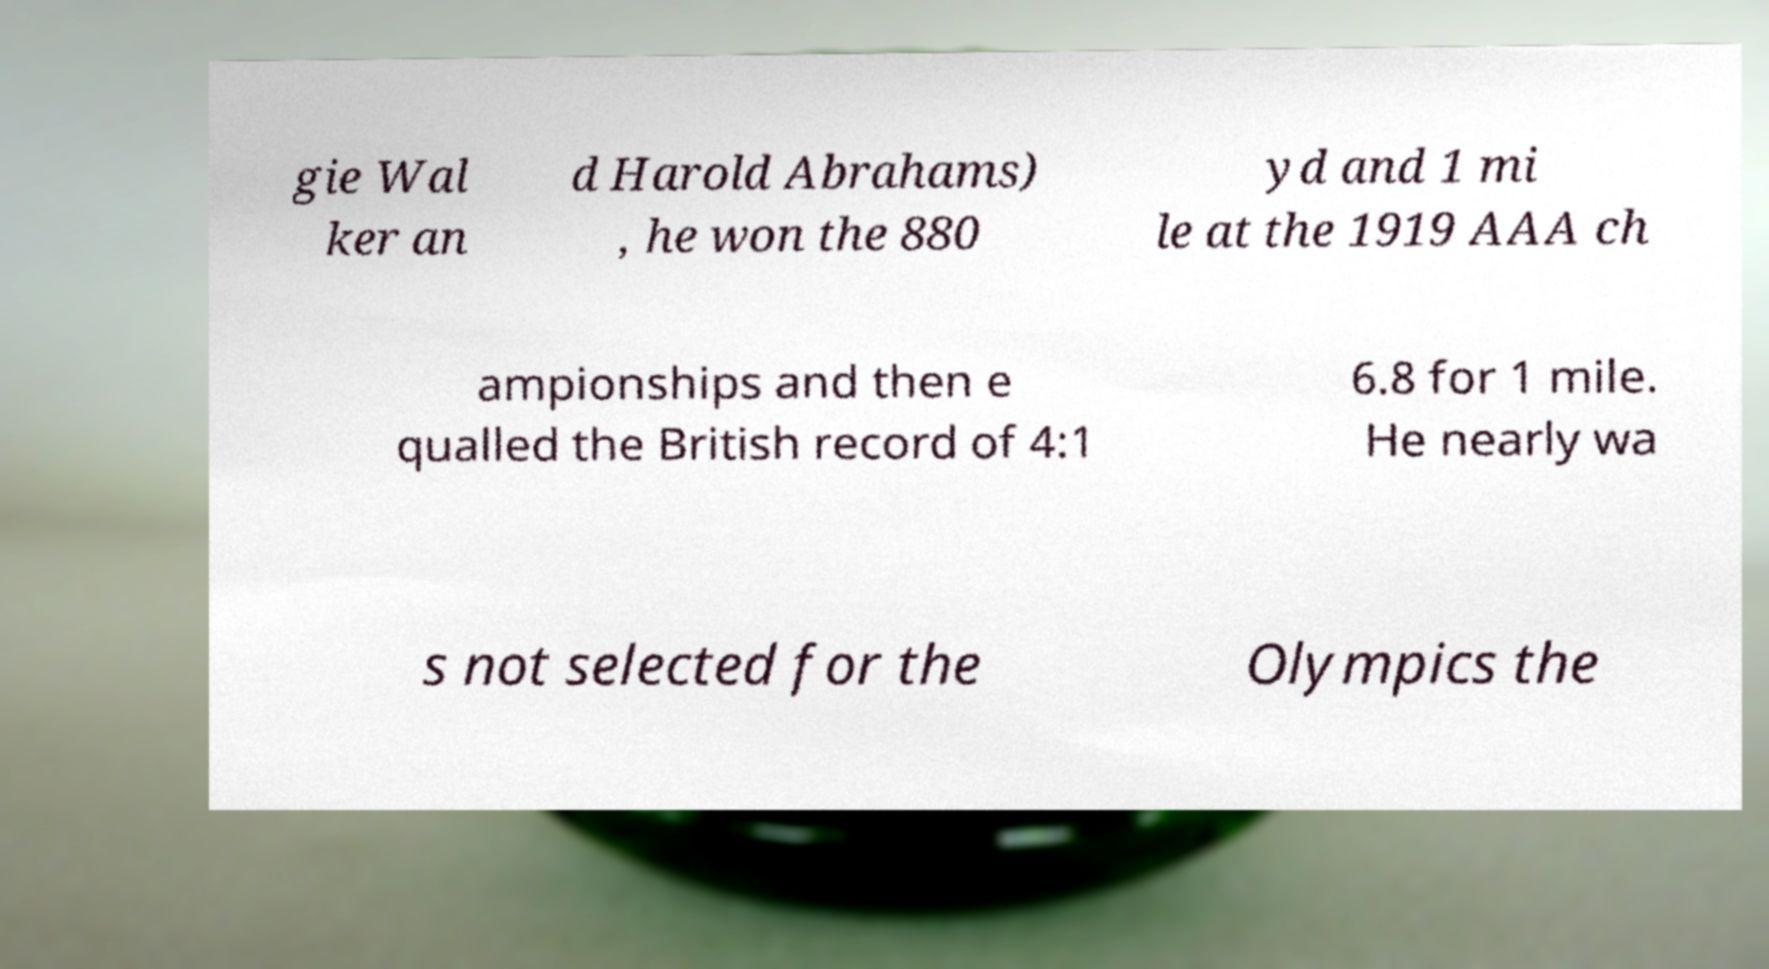What messages or text are displayed in this image? I need them in a readable, typed format. gie Wal ker an d Harold Abrahams) , he won the 880 yd and 1 mi le at the 1919 AAA ch ampionships and then e qualled the British record of 4:1 6.8 for 1 mile. He nearly wa s not selected for the Olympics the 